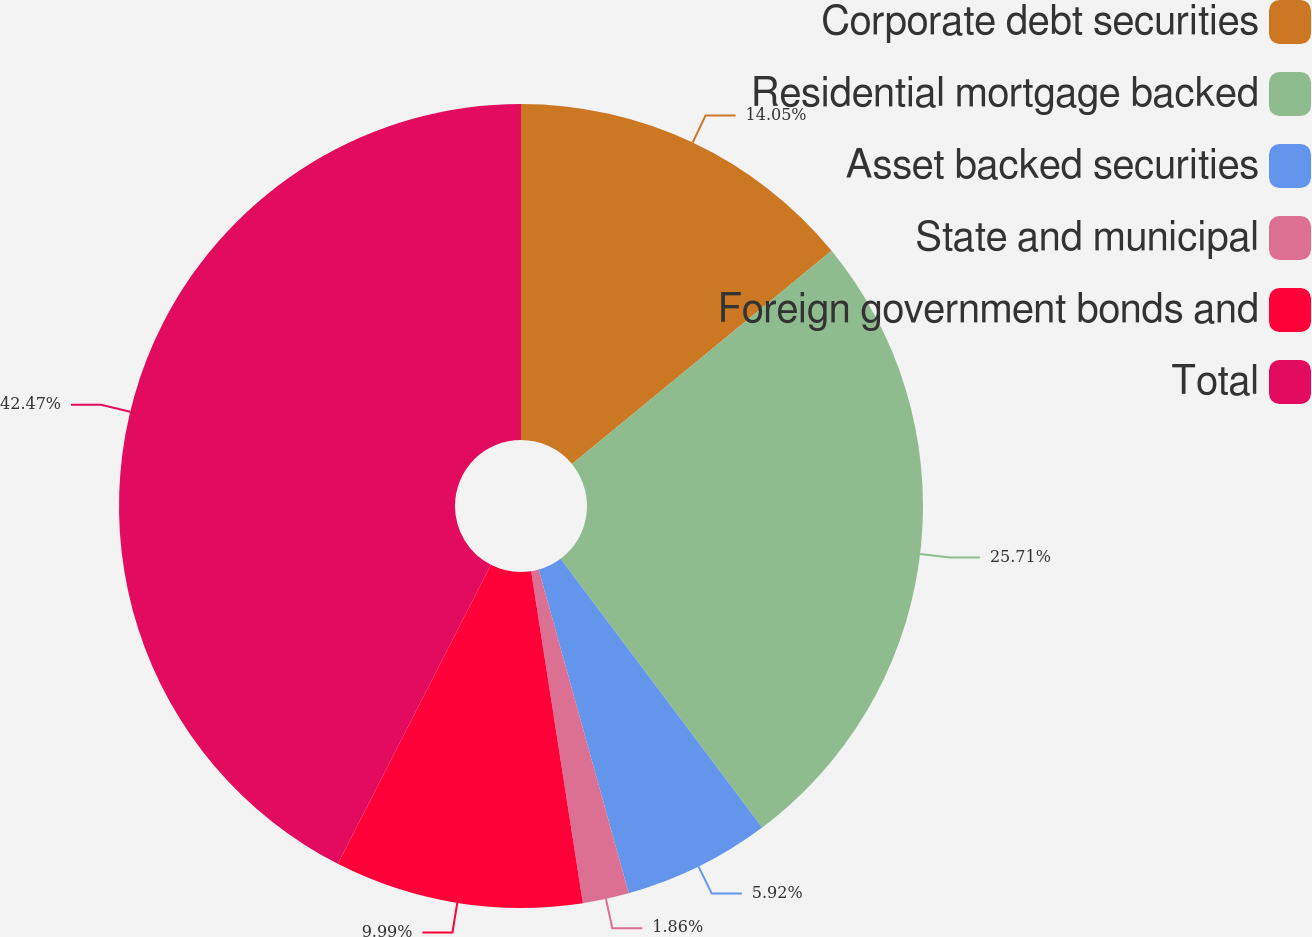Convert chart. <chart><loc_0><loc_0><loc_500><loc_500><pie_chart><fcel>Corporate debt securities<fcel>Residential mortgage backed<fcel>Asset backed securities<fcel>State and municipal<fcel>Foreign government bonds and<fcel>Total<nl><fcel>14.05%<fcel>25.71%<fcel>5.92%<fcel>1.86%<fcel>9.99%<fcel>42.47%<nl></chart> 